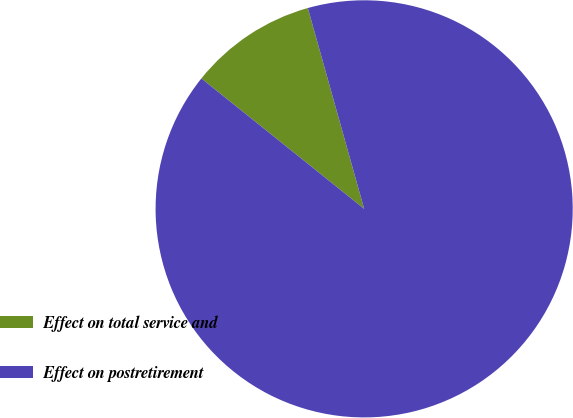<chart> <loc_0><loc_0><loc_500><loc_500><pie_chart><fcel>Effect on total service and<fcel>Effect on postretirement<nl><fcel>9.9%<fcel>90.1%<nl></chart> 